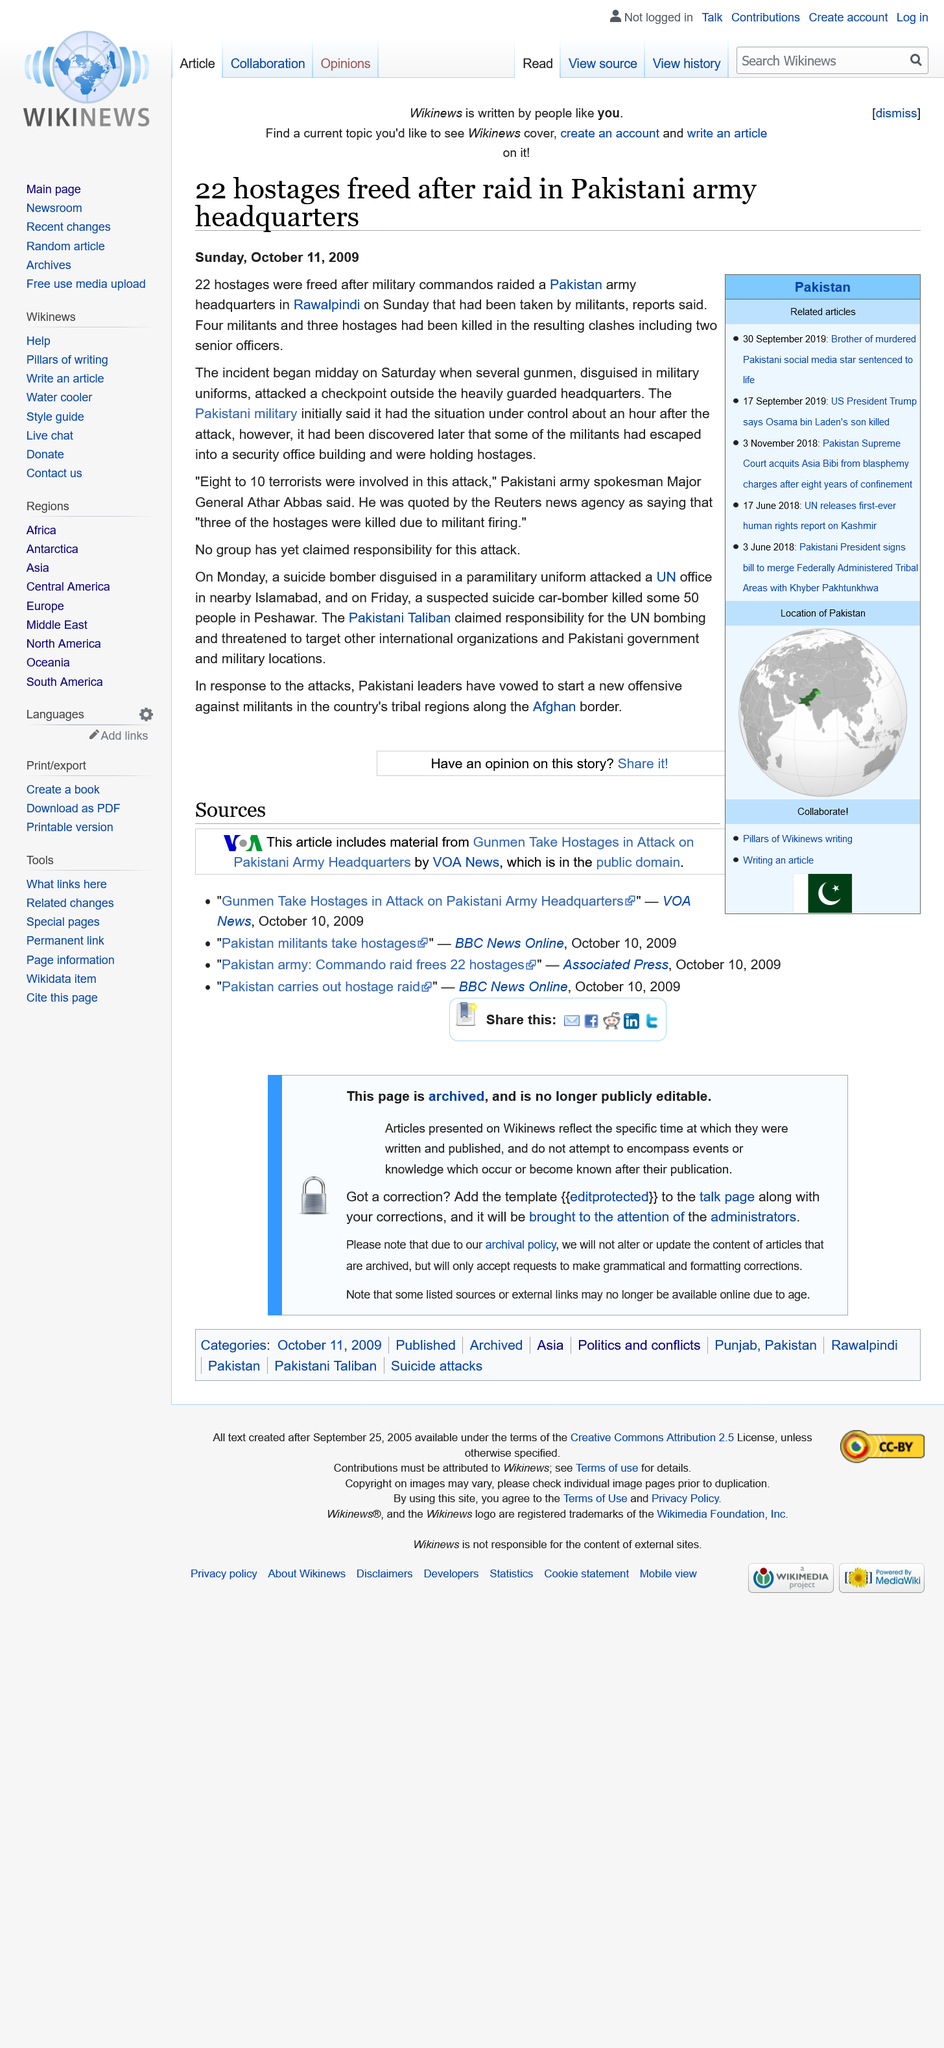Draw attention to some important aspects in this diagram. No entity has yet claimed responsibility for the attack and hostage situation at the checkpoint. Major General Athar Abbas is the Pakistani army spokesman quoted in the report. Military commandos successfully freed 22 hostages after raiding a Pakistan army headquarters. 